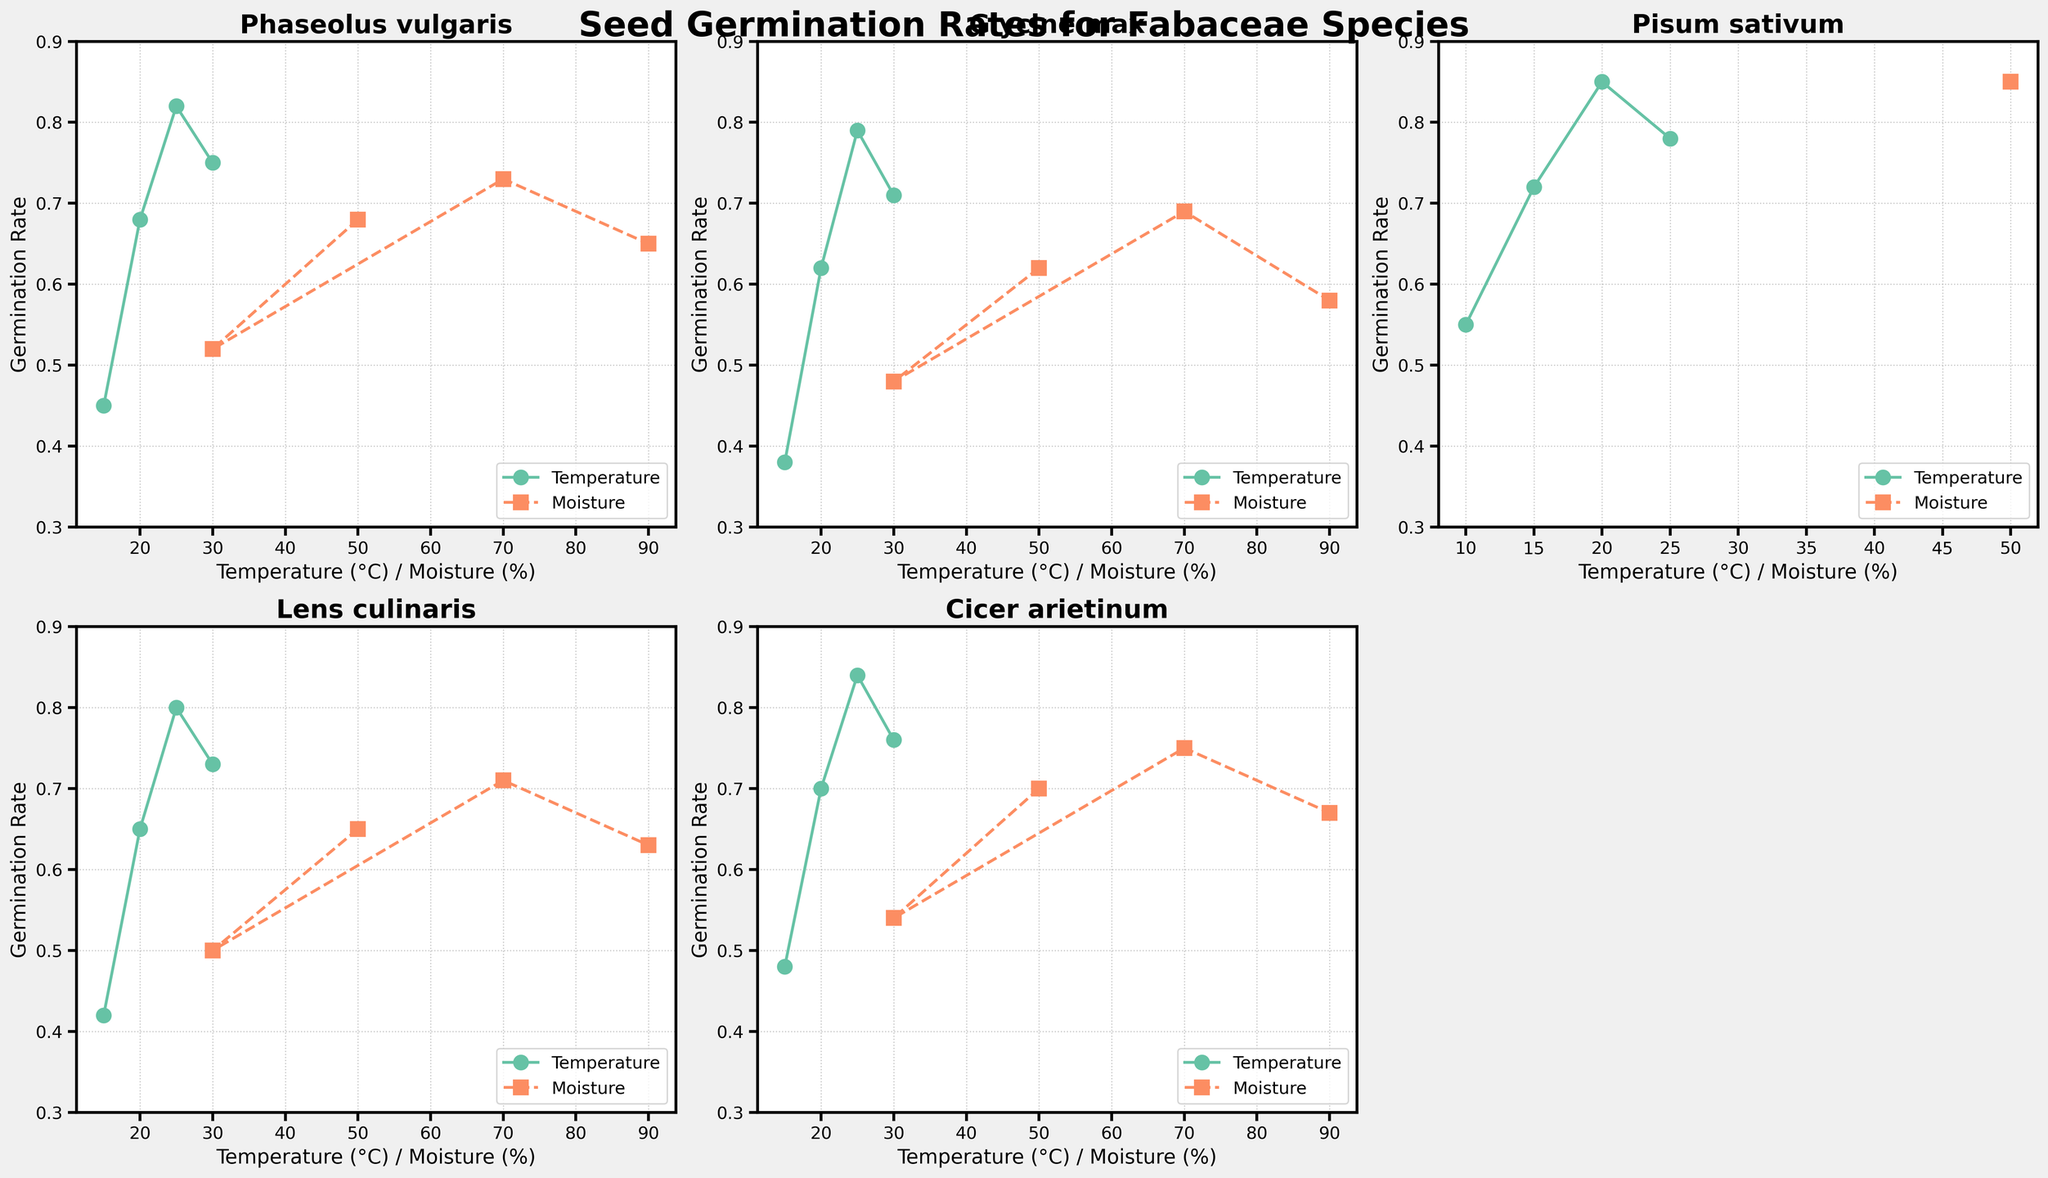Which species has the highest germination rate at 25°C and 50% moisture? To find the species with the highest germination rate at 25°C and 50% moisture, look at the points for 25°C and 50% moisture in each subplot. The highest rate is for Pisum sativum with 0.85.
Answer: Pisum sativum Which species shows the most significant increase in germination rate when the temperature increases from 15°C to 20°C with 50% moisture? Compare the germination rates at 15°C and 20°C for 50% moisture in each subplot. The increases are:
- Phaseolus vulgaris: 0.23
- Glycine max: 0.24
- Pisum sativum: 0.13
- Lens culinaris: 0.23
- Cicer arietinum: 0.22
The most significant increase is for Glycine max.
Answer: Glycine max Which species has the most significant decrease in germination rate when the moisture is increased from 70% to 90% at 20°C? Compare the germination rates at 70% and 90% moisture for 20°C in each subplot. The decreases are:
- Phaseolus vulgaris: 0.08
- Glycine max: 0.11
- Pisum sativum: 0.08
- Lens culinaris: 0.08
- Cicer arietinum: 0.08
The most significant decrease is for Glycine max.
Answer: Glycine max Which species shows the least variațion in germination rates across different moisture levels at 20°C? Compare the ranges of germination rates for different moisture levels (30%, 70%, 90%) at 20°C in each subplot. The ranges are:
- Phaseolus vulgaris: 0.52 - 0.73 = 0.21
- Glycine max: 0.48 - 0.69 = 0.21
- Pisum sativum: 0.58 - 0.76 = 0.18
- Lens culinaris: 0.50 - 0.71 = 0.21
- Cicer arietinum: 0.54 - 0.75 = 0.21
The least variation is for Pisum sativum.
Answer: Pisum sativum Which moisture condition results in the highest germination rate for Lens culinaris at 20°C? Look at the germination rates for different moisture levels (30%, 70%, 90%) at 20°C for Lens culinaris. The highest rate is for 70% moisture with a rate of 0.71.
Answer: 70% What is the average germination rate for Phaseolus vulgaris across all tested temperatures with 50% moisture? Sum the germination rates for different temperatures (15°C, 20°C, 25°C, 30°C) with 50% moisture for Phaseolus vulgaris and divide by the number of data points: (0.45 + 0.68 + 0.82 + 0.75) / 4 = 2.70 / 4 = 0.675.
Answer: 0.675 How does the germination rate for Pisum sativum change when the temperature increases from 10°C to 20°C with 50% moisture? Check the germination rates for 10°C, 15°C, and 20°C with 50% moisture for Pisum sativum. The increase from 10°C (0.55) to 15°C (0.72) is 0.17, and from 15°C to 20°C (0.85) is 0.13, totaling a change of 0.30.
Answer: Increases by 0.30 Which species has the highest germination rate at a moisture level of 30%? Compare the germination rates at 30% moisture across all species at their respective optimal temperatures for this moisture level (15°C for Pisum sativum and 20°C for others). The highest rate is for Cicer arietinum at 20°C (0.54).
Answer: Cicer arietinum 